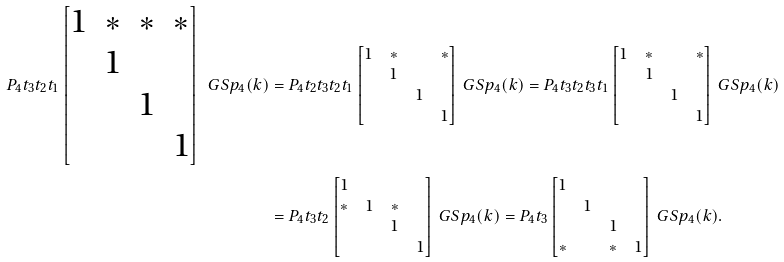<formula> <loc_0><loc_0><loc_500><loc_500>P _ { 4 } t _ { 3 } t _ { 2 } t _ { 1 } \begin{bmatrix} 1 & * & * & * \\ & 1 \\ & & 1 \\ & & & 1 \end{bmatrix} \ G S p _ { 4 } ( k ) & = P _ { 4 } t _ { 2 } t _ { 3 } t _ { 2 } t _ { 1 } \begin{bmatrix} 1 & * & & * \\ & 1 \\ & & 1 \\ & & & 1 \end{bmatrix} \ G S p _ { 4 } ( k ) = P _ { 4 } t _ { 3 } t _ { 2 } t _ { 3 } t _ { 1 } \begin{bmatrix} 1 & * & & * \\ & 1 \\ & & 1 \\ & & & 1 \end{bmatrix} \ G S p _ { 4 } ( k ) \\ & = P _ { 4 } t _ { 3 } t _ { 2 } \begin{bmatrix} 1 \\ * & 1 & * \\ & & 1 & \\ & & & 1 \end{bmatrix} \ G S p _ { 4 } ( k ) = P _ { 4 } t _ { 3 } \begin{bmatrix} 1 \\ & 1 \\ & & 1 & \\ * & & * & 1 \end{bmatrix} \ G S p _ { 4 } ( k ) .</formula> 